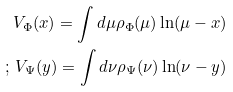<formula> <loc_0><loc_0><loc_500><loc_500>V _ { \Phi } ( x ) = \int d \mu \rho _ { \Phi } ( \mu ) \ln ( \mu - x ) \\ ; \, V _ { \Psi } ( y ) = \int d \nu \rho _ { \Psi } ( \nu ) \ln ( \nu - y )</formula> 